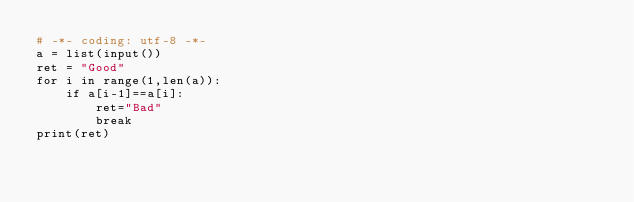<code> <loc_0><loc_0><loc_500><loc_500><_Python_># -*- coding: utf-8 -*-
a = list(input())
ret = "Good"
for i in range(1,len(a)):
    if a[i-1]==a[i]:
        ret="Bad"
        break
print(ret)
</code> 